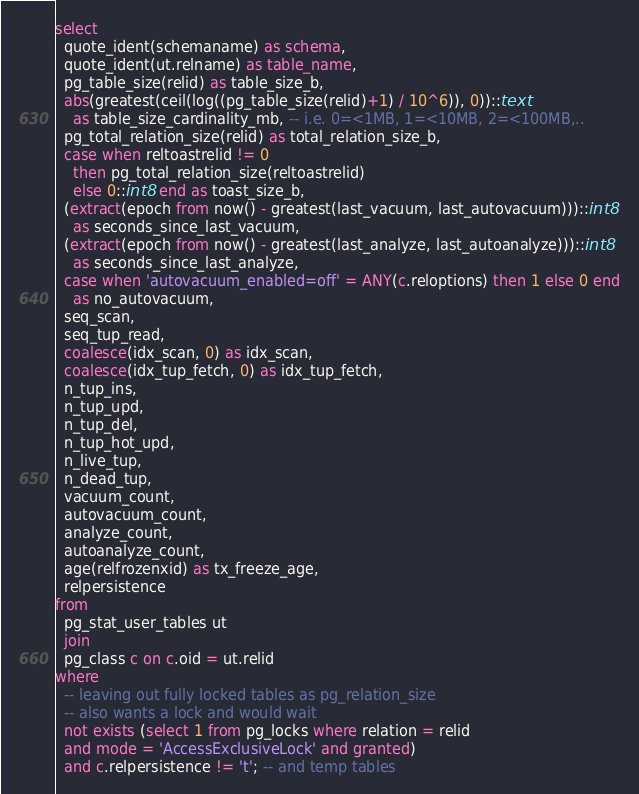Convert code to text. <code><loc_0><loc_0><loc_500><loc_500><_SQL_>select
  quote_ident(schemaname) as schema,
  quote_ident(ut.relname) as table_name,
  pg_table_size(relid) as table_size_b,
  abs(greatest(ceil(log((pg_table_size(relid)+1) / 10^6)), 0))::text
    as table_size_cardinality_mb, -- i.e. 0=<1MB, 1=<10MB, 2=<100MB,..
  pg_total_relation_size(relid) as total_relation_size_b,
  case when reltoastrelid != 0
    then pg_total_relation_size(reltoastrelid)
    else 0::int8 end as toast_size_b,
  (extract(epoch from now() - greatest(last_vacuum, last_autovacuum)))::int8
    as seconds_since_last_vacuum,
  (extract(epoch from now() - greatest(last_analyze, last_autoanalyze)))::int8
    as seconds_since_last_analyze,
  case when 'autovacuum_enabled=off' = ANY(c.reloptions) then 1 else 0 end
    as no_autovacuum,
  seq_scan,
  seq_tup_read,
  coalesce(idx_scan, 0) as idx_scan,
  coalesce(idx_tup_fetch, 0) as idx_tup_fetch,
  n_tup_ins,
  n_tup_upd,
  n_tup_del,
  n_tup_hot_upd,
  n_live_tup,
  n_dead_tup,
  vacuum_count,
  autovacuum_count,
  analyze_count,
  autoanalyze_count,
  age(relfrozenxid) as tx_freeze_age,
  relpersistence
from
  pg_stat_user_tables ut
  join
  pg_class c on c.oid = ut.relid
where
  -- leaving out fully locked tables as pg_relation_size
  -- also wants a lock and would wait
  not exists (select 1 from pg_locks where relation = relid
  and mode = 'AccessExclusiveLock' and granted)
  and c.relpersistence != 't'; -- and temp tables
</code> 